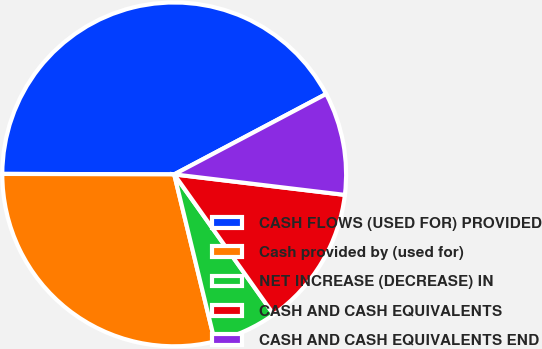Convert chart. <chart><loc_0><loc_0><loc_500><loc_500><pie_chart><fcel>CASH FLOWS (USED FOR) PROVIDED<fcel>Cash provided by (used for)<fcel>NET INCREASE (DECREASE) IN<fcel>CASH AND CASH EQUIVALENTS<fcel>CASH AND CASH EQUIVALENTS END<nl><fcel>42.21%<fcel>28.84%<fcel>6.03%<fcel>13.27%<fcel>9.65%<nl></chart> 